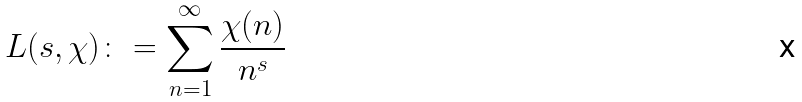<formula> <loc_0><loc_0><loc_500><loc_500>L ( s , \chi ) \colon = \sum _ { n = 1 } ^ { \infty } \frac { \chi ( n ) } { n ^ { s } }</formula> 